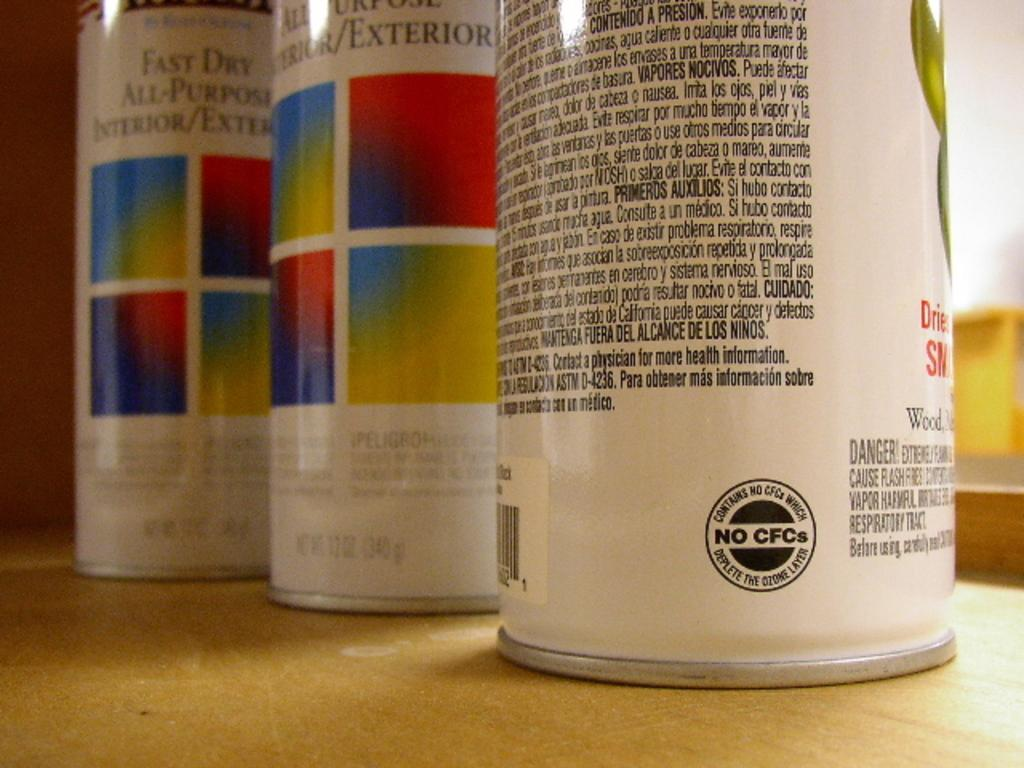<image>
Present a compact description of the photo's key features. a logo on an item that says No CFCs on it 